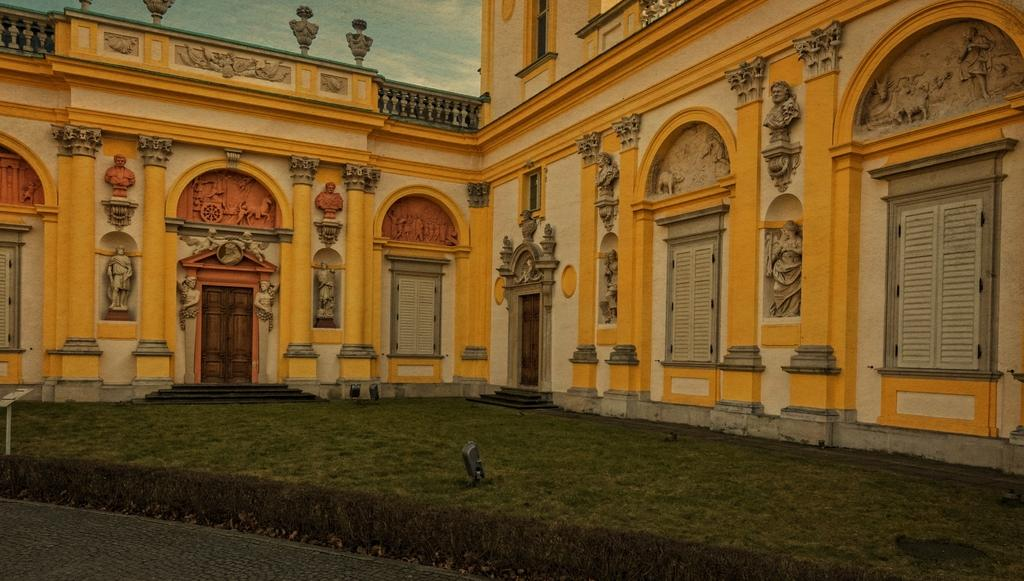What type of structure is present in the image? There is a building in the image. What artistic elements can be seen in the image? There are sculptures in the image. What can be seen in the sky in the image? The sky is visible in the image. How can one access the building in the image? There are stairs in the image that provide access to the building. What is a feature of the building that allows for light and visibility? There is a door in the image that provides access to the building's interior. What material is present in the image that is typically used for windows? There is glass in the image, which is commonly used for windows. What type of window treatment is visible in the image? There are window blinds in the image. What type of jam is being served at the organization's summer event in the image? There is no jam, organization, or summer event present in the image. 